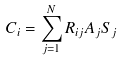<formula> <loc_0><loc_0><loc_500><loc_500>C _ { i } = \sum _ { j = 1 } ^ { N } R _ { i j } A _ { j } S _ { j }</formula> 